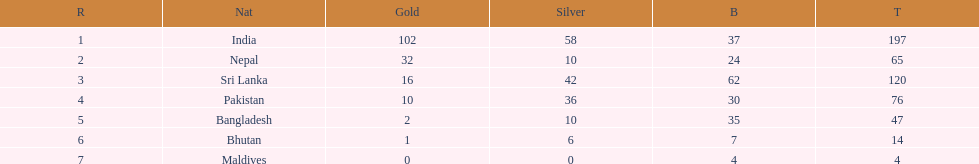What was the number of silver medals won by pakistan? 36. 